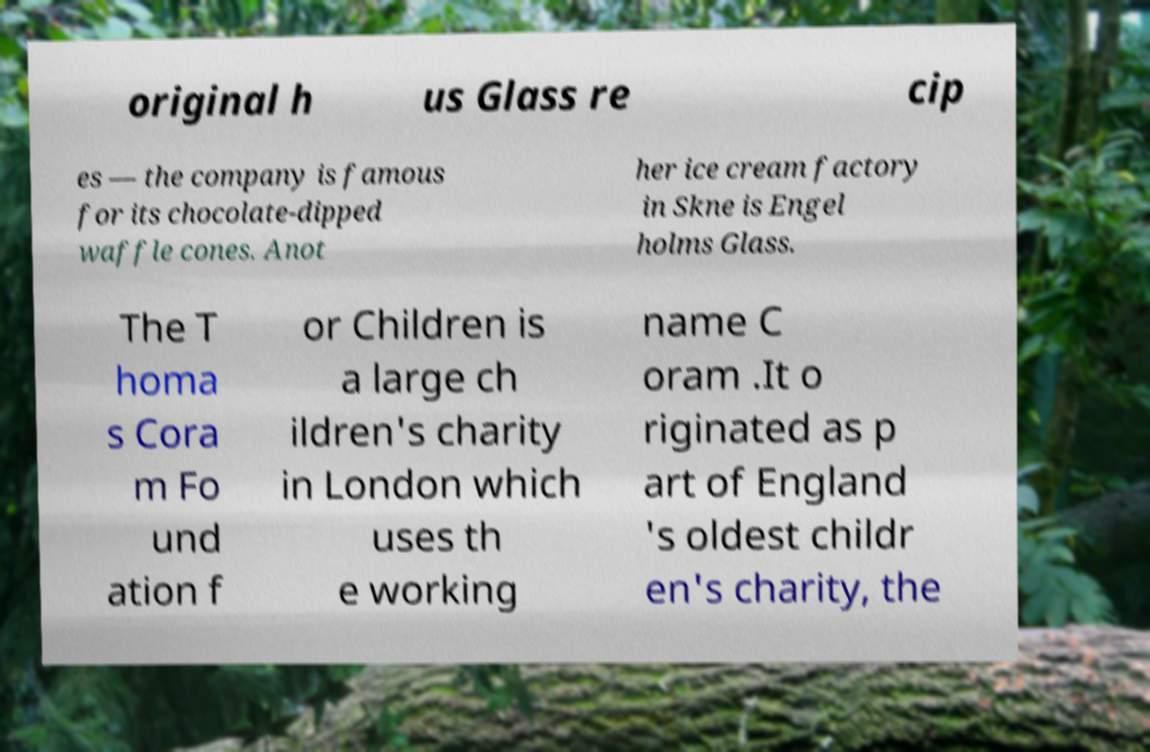Can you read and provide the text displayed in the image?This photo seems to have some interesting text. Can you extract and type it out for me? original h us Glass re cip es — the company is famous for its chocolate-dipped waffle cones. Anot her ice cream factory in Skne is Engel holms Glass. The T homa s Cora m Fo und ation f or Children is a large ch ildren's charity in London which uses th e working name C oram .It o riginated as p art of England 's oldest childr en's charity, the 